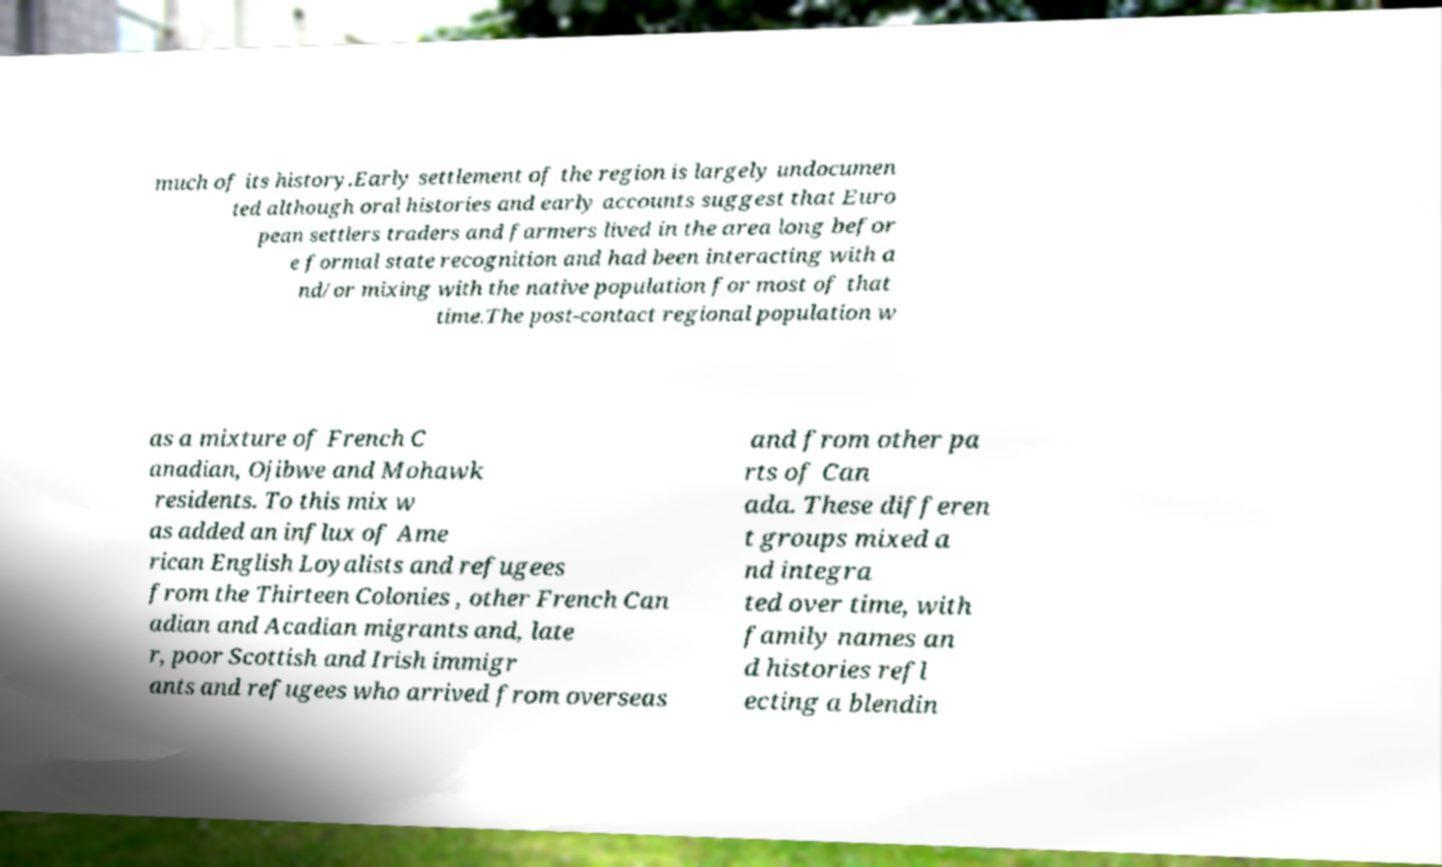I need the written content from this picture converted into text. Can you do that? much of its history.Early settlement of the region is largely undocumen ted although oral histories and early accounts suggest that Euro pean settlers traders and farmers lived in the area long befor e formal state recognition and had been interacting with a nd/or mixing with the native population for most of that time.The post-contact regional population w as a mixture of French C anadian, Ojibwe and Mohawk residents. To this mix w as added an influx of Ame rican English Loyalists and refugees from the Thirteen Colonies , other French Can adian and Acadian migrants and, late r, poor Scottish and Irish immigr ants and refugees who arrived from overseas and from other pa rts of Can ada. These differen t groups mixed a nd integra ted over time, with family names an d histories refl ecting a blendin 